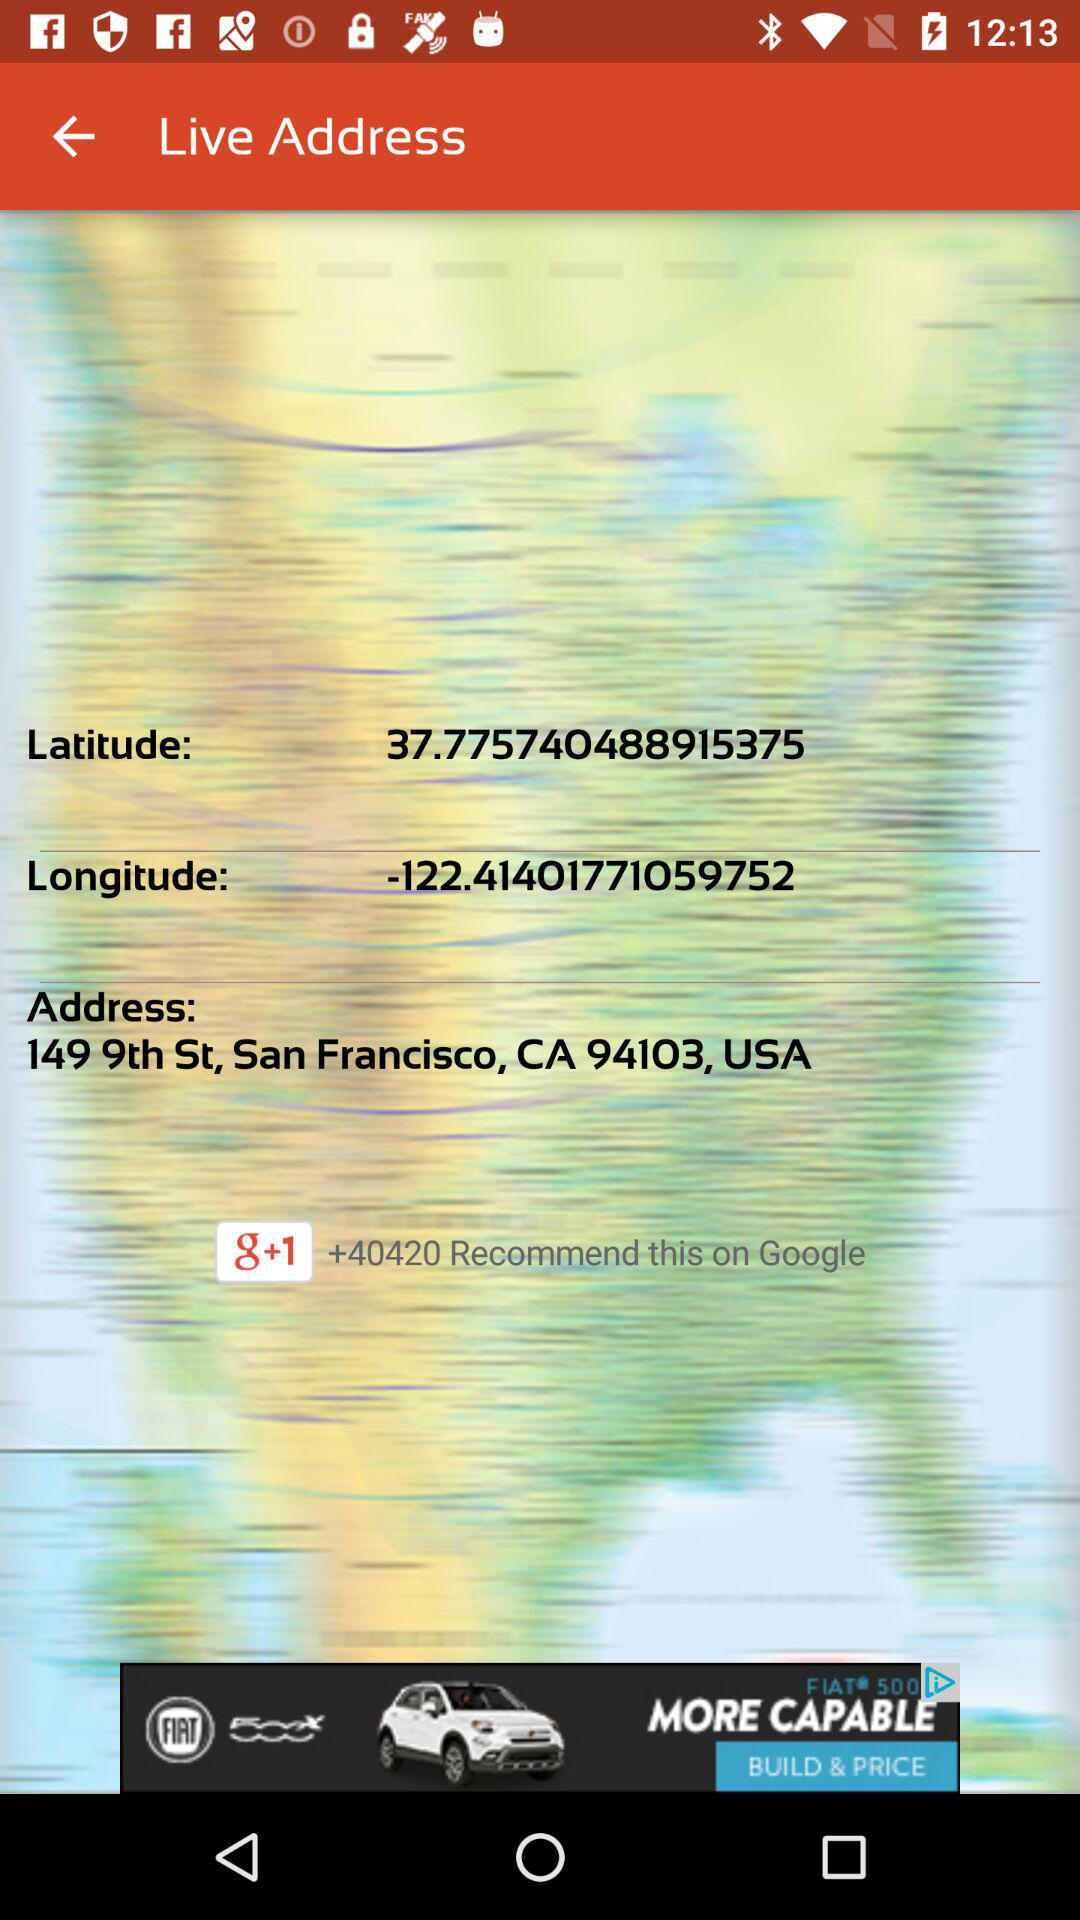What is the mentioned longitude? The mentioned longitude is -122.41401771059752. 